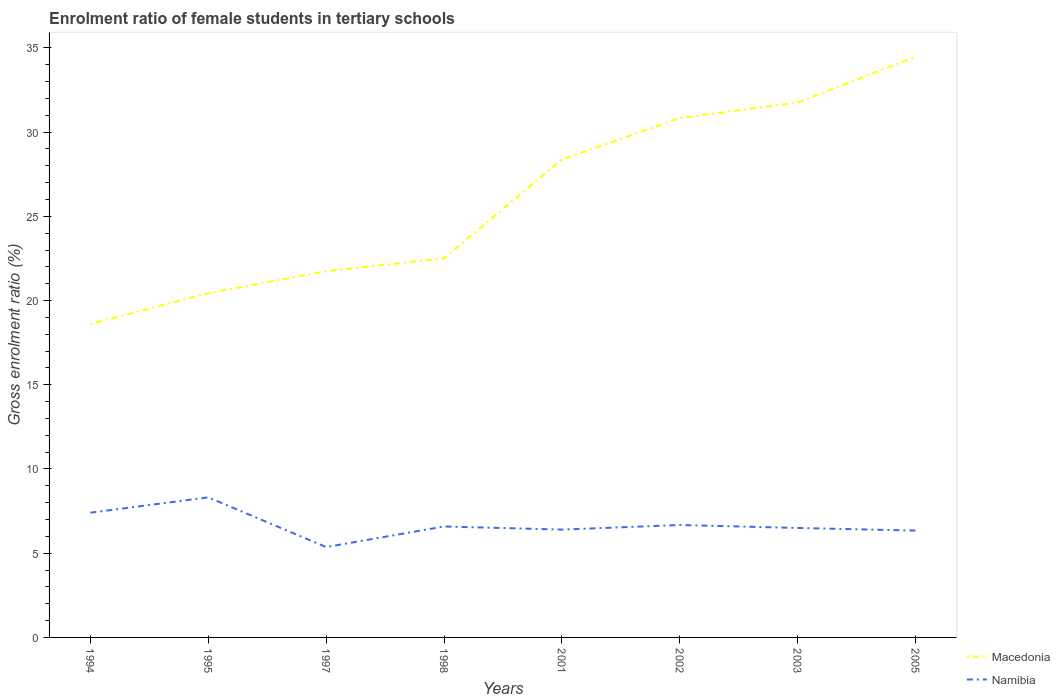How many different coloured lines are there?
Offer a terse response. 2. Does the line corresponding to Macedonia intersect with the line corresponding to Namibia?
Make the answer very short. No. Is the number of lines equal to the number of legend labels?
Your answer should be compact. Yes. Across all years, what is the maximum enrolment ratio of female students in tertiary schools in Namibia?
Offer a terse response. 5.36. In which year was the enrolment ratio of female students in tertiary schools in Namibia maximum?
Keep it short and to the point. 1997. What is the total enrolment ratio of female students in tertiary schools in Macedonia in the graph?
Provide a short and direct response. -2.45. What is the difference between the highest and the second highest enrolment ratio of female students in tertiary schools in Macedonia?
Give a very brief answer. 15.86. What is the difference between the highest and the lowest enrolment ratio of female students in tertiary schools in Namibia?
Ensure brevity in your answer.  2. How many years are there in the graph?
Keep it short and to the point. 8. Does the graph contain any zero values?
Your response must be concise. No. How many legend labels are there?
Make the answer very short. 2. What is the title of the graph?
Ensure brevity in your answer.  Enrolment ratio of female students in tertiary schools. What is the Gross enrolment ratio (%) in Macedonia in 1994?
Offer a very short reply. 18.61. What is the Gross enrolment ratio (%) in Namibia in 1994?
Ensure brevity in your answer.  7.41. What is the Gross enrolment ratio (%) in Macedonia in 1995?
Make the answer very short. 20.43. What is the Gross enrolment ratio (%) in Namibia in 1995?
Your response must be concise. 8.32. What is the Gross enrolment ratio (%) in Macedonia in 1997?
Give a very brief answer. 21.74. What is the Gross enrolment ratio (%) of Namibia in 1997?
Your answer should be very brief. 5.36. What is the Gross enrolment ratio (%) of Macedonia in 1998?
Your response must be concise. 22.5. What is the Gross enrolment ratio (%) in Namibia in 1998?
Keep it short and to the point. 6.59. What is the Gross enrolment ratio (%) of Macedonia in 2001?
Provide a short and direct response. 28.38. What is the Gross enrolment ratio (%) in Namibia in 2001?
Ensure brevity in your answer.  6.4. What is the Gross enrolment ratio (%) of Macedonia in 2002?
Provide a succinct answer. 30.83. What is the Gross enrolment ratio (%) of Namibia in 2002?
Provide a succinct answer. 6.67. What is the Gross enrolment ratio (%) in Macedonia in 2003?
Provide a succinct answer. 31.76. What is the Gross enrolment ratio (%) of Namibia in 2003?
Your response must be concise. 6.5. What is the Gross enrolment ratio (%) of Macedonia in 2005?
Provide a short and direct response. 34.47. What is the Gross enrolment ratio (%) in Namibia in 2005?
Keep it short and to the point. 6.34. Across all years, what is the maximum Gross enrolment ratio (%) in Macedonia?
Provide a short and direct response. 34.47. Across all years, what is the maximum Gross enrolment ratio (%) of Namibia?
Provide a short and direct response. 8.32. Across all years, what is the minimum Gross enrolment ratio (%) in Macedonia?
Give a very brief answer. 18.61. Across all years, what is the minimum Gross enrolment ratio (%) in Namibia?
Your answer should be very brief. 5.36. What is the total Gross enrolment ratio (%) in Macedonia in the graph?
Give a very brief answer. 208.73. What is the total Gross enrolment ratio (%) in Namibia in the graph?
Your answer should be compact. 53.59. What is the difference between the Gross enrolment ratio (%) in Macedonia in 1994 and that in 1995?
Keep it short and to the point. -1.82. What is the difference between the Gross enrolment ratio (%) in Namibia in 1994 and that in 1995?
Give a very brief answer. -0.91. What is the difference between the Gross enrolment ratio (%) in Macedonia in 1994 and that in 1997?
Your answer should be very brief. -3.13. What is the difference between the Gross enrolment ratio (%) of Namibia in 1994 and that in 1997?
Keep it short and to the point. 2.04. What is the difference between the Gross enrolment ratio (%) in Macedonia in 1994 and that in 1998?
Ensure brevity in your answer.  -3.89. What is the difference between the Gross enrolment ratio (%) in Namibia in 1994 and that in 1998?
Ensure brevity in your answer.  0.82. What is the difference between the Gross enrolment ratio (%) in Macedonia in 1994 and that in 2001?
Offer a very short reply. -9.77. What is the difference between the Gross enrolment ratio (%) in Namibia in 1994 and that in 2001?
Keep it short and to the point. 1. What is the difference between the Gross enrolment ratio (%) of Macedonia in 1994 and that in 2002?
Offer a very short reply. -12.22. What is the difference between the Gross enrolment ratio (%) in Namibia in 1994 and that in 2002?
Offer a terse response. 0.73. What is the difference between the Gross enrolment ratio (%) of Macedonia in 1994 and that in 2003?
Ensure brevity in your answer.  -13.15. What is the difference between the Gross enrolment ratio (%) in Namibia in 1994 and that in 2003?
Offer a terse response. 0.91. What is the difference between the Gross enrolment ratio (%) in Macedonia in 1994 and that in 2005?
Your answer should be compact. -15.86. What is the difference between the Gross enrolment ratio (%) of Namibia in 1994 and that in 2005?
Give a very brief answer. 1.06. What is the difference between the Gross enrolment ratio (%) of Macedonia in 1995 and that in 1997?
Provide a succinct answer. -1.31. What is the difference between the Gross enrolment ratio (%) of Namibia in 1995 and that in 1997?
Your response must be concise. 2.95. What is the difference between the Gross enrolment ratio (%) of Macedonia in 1995 and that in 1998?
Provide a short and direct response. -2.07. What is the difference between the Gross enrolment ratio (%) in Namibia in 1995 and that in 1998?
Your answer should be compact. 1.73. What is the difference between the Gross enrolment ratio (%) in Macedonia in 1995 and that in 2001?
Your answer should be compact. -7.94. What is the difference between the Gross enrolment ratio (%) in Namibia in 1995 and that in 2001?
Your answer should be very brief. 1.91. What is the difference between the Gross enrolment ratio (%) of Macedonia in 1995 and that in 2002?
Your answer should be compact. -10.39. What is the difference between the Gross enrolment ratio (%) in Namibia in 1995 and that in 2002?
Your response must be concise. 1.64. What is the difference between the Gross enrolment ratio (%) in Macedonia in 1995 and that in 2003?
Offer a terse response. -11.32. What is the difference between the Gross enrolment ratio (%) in Namibia in 1995 and that in 2003?
Make the answer very short. 1.82. What is the difference between the Gross enrolment ratio (%) in Macedonia in 1995 and that in 2005?
Provide a short and direct response. -14.04. What is the difference between the Gross enrolment ratio (%) of Namibia in 1995 and that in 2005?
Provide a short and direct response. 1.97. What is the difference between the Gross enrolment ratio (%) of Macedonia in 1997 and that in 1998?
Make the answer very short. -0.76. What is the difference between the Gross enrolment ratio (%) in Namibia in 1997 and that in 1998?
Your answer should be compact. -1.22. What is the difference between the Gross enrolment ratio (%) of Macedonia in 1997 and that in 2001?
Make the answer very short. -6.64. What is the difference between the Gross enrolment ratio (%) of Namibia in 1997 and that in 2001?
Your answer should be compact. -1.04. What is the difference between the Gross enrolment ratio (%) of Macedonia in 1997 and that in 2002?
Ensure brevity in your answer.  -9.09. What is the difference between the Gross enrolment ratio (%) in Namibia in 1997 and that in 2002?
Your answer should be compact. -1.31. What is the difference between the Gross enrolment ratio (%) in Macedonia in 1997 and that in 2003?
Offer a terse response. -10.02. What is the difference between the Gross enrolment ratio (%) in Namibia in 1997 and that in 2003?
Offer a very short reply. -1.14. What is the difference between the Gross enrolment ratio (%) in Macedonia in 1997 and that in 2005?
Your response must be concise. -12.73. What is the difference between the Gross enrolment ratio (%) of Namibia in 1997 and that in 2005?
Keep it short and to the point. -0.98. What is the difference between the Gross enrolment ratio (%) in Macedonia in 1998 and that in 2001?
Your answer should be compact. -5.88. What is the difference between the Gross enrolment ratio (%) of Namibia in 1998 and that in 2001?
Make the answer very short. 0.18. What is the difference between the Gross enrolment ratio (%) in Macedonia in 1998 and that in 2002?
Give a very brief answer. -8.33. What is the difference between the Gross enrolment ratio (%) of Namibia in 1998 and that in 2002?
Your answer should be compact. -0.09. What is the difference between the Gross enrolment ratio (%) in Macedonia in 1998 and that in 2003?
Provide a short and direct response. -9.26. What is the difference between the Gross enrolment ratio (%) of Namibia in 1998 and that in 2003?
Give a very brief answer. 0.09. What is the difference between the Gross enrolment ratio (%) in Macedonia in 1998 and that in 2005?
Provide a succinct answer. -11.97. What is the difference between the Gross enrolment ratio (%) of Namibia in 1998 and that in 2005?
Give a very brief answer. 0.24. What is the difference between the Gross enrolment ratio (%) in Macedonia in 2001 and that in 2002?
Your answer should be compact. -2.45. What is the difference between the Gross enrolment ratio (%) of Namibia in 2001 and that in 2002?
Ensure brevity in your answer.  -0.27. What is the difference between the Gross enrolment ratio (%) in Macedonia in 2001 and that in 2003?
Make the answer very short. -3.38. What is the difference between the Gross enrolment ratio (%) of Namibia in 2001 and that in 2003?
Offer a terse response. -0.1. What is the difference between the Gross enrolment ratio (%) in Macedonia in 2001 and that in 2005?
Provide a short and direct response. -6.09. What is the difference between the Gross enrolment ratio (%) in Namibia in 2001 and that in 2005?
Provide a short and direct response. 0.06. What is the difference between the Gross enrolment ratio (%) in Macedonia in 2002 and that in 2003?
Your answer should be very brief. -0.93. What is the difference between the Gross enrolment ratio (%) of Namibia in 2002 and that in 2003?
Provide a succinct answer. 0.18. What is the difference between the Gross enrolment ratio (%) in Macedonia in 2002 and that in 2005?
Your answer should be very brief. -3.64. What is the difference between the Gross enrolment ratio (%) of Namibia in 2002 and that in 2005?
Your answer should be very brief. 0.33. What is the difference between the Gross enrolment ratio (%) of Macedonia in 2003 and that in 2005?
Give a very brief answer. -2.71. What is the difference between the Gross enrolment ratio (%) in Namibia in 2003 and that in 2005?
Ensure brevity in your answer.  0.16. What is the difference between the Gross enrolment ratio (%) of Macedonia in 1994 and the Gross enrolment ratio (%) of Namibia in 1995?
Make the answer very short. 10.29. What is the difference between the Gross enrolment ratio (%) in Macedonia in 1994 and the Gross enrolment ratio (%) in Namibia in 1997?
Provide a succinct answer. 13.25. What is the difference between the Gross enrolment ratio (%) of Macedonia in 1994 and the Gross enrolment ratio (%) of Namibia in 1998?
Your answer should be very brief. 12.02. What is the difference between the Gross enrolment ratio (%) of Macedonia in 1994 and the Gross enrolment ratio (%) of Namibia in 2001?
Make the answer very short. 12.21. What is the difference between the Gross enrolment ratio (%) of Macedonia in 1994 and the Gross enrolment ratio (%) of Namibia in 2002?
Make the answer very short. 11.94. What is the difference between the Gross enrolment ratio (%) in Macedonia in 1994 and the Gross enrolment ratio (%) in Namibia in 2003?
Provide a short and direct response. 12.11. What is the difference between the Gross enrolment ratio (%) of Macedonia in 1994 and the Gross enrolment ratio (%) of Namibia in 2005?
Keep it short and to the point. 12.27. What is the difference between the Gross enrolment ratio (%) in Macedonia in 1995 and the Gross enrolment ratio (%) in Namibia in 1997?
Provide a succinct answer. 15.07. What is the difference between the Gross enrolment ratio (%) of Macedonia in 1995 and the Gross enrolment ratio (%) of Namibia in 1998?
Ensure brevity in your answer.  13.85. What is the difference between the Gross enrolment ratio (%) in Macedonia in 1995 and the Gross enrolment ratio (%) in Namibia in 2001?
Keep it short and to the point. 14.03. What is the difference between the Gross enrolment ratio (%) of Macedonia in 1995 and the Gross enrolment ratio (%) of Namibia in 2002?
Give a very brief answer. 13.76. What is the difference between the Gross enrolment ratio (%) of Macedonia in 1995 and the Gross enrolment ratio (%) of Namibia in 2003?
Your response must be concise. 13.94. What is the difference between the Gross enrolment ratio (%) in Macedonia in 1995 and the Gross enrolment ratio (%) in Namibia in 2005?
Your response must be concise. 14.09. What is the difference between the Gross enrolment ratio (%) in Macedonia in 1997 and the Gross enrolment ratio (%) in Namibia in 1998?
Provide a succinct answer. 15.16. What is the difference between the Gross enrolment ratio (%) of Macedonia in 1997 and the Gross enrolment ratio (%) of Namibia in 2001?
Provide a short and direct response. 15.34. What is the difference between the Gross enrolment ratio (%) of Macedonia in 1997 and the Gross enrolment ratio (%) of Namibia in 2002?
Offer a very short reply. 15.07. What is the difference between the Gross enrolment ratio (%) in Macedonia in 1997 and the Gross enrolment ratio (%) in Namibia in 2003?
Offer a very short reply. 15.24. What is the difference between the Gross enrolment ratio (%) of Macedonia in 1997 and the Gross enrolment ratio (%) of Namibia in 2005?
Keep it short and to the point. 15.4. What is the difference between the Gross enrolment ratio (%) in Macedonia in 1998 and the Gross enrolment ratio (%) in Namibia in 2001?
Provide a short and direct response. 16.1. What is the difference between the Gross enrolment ratio (%) in Macedonia in 1998 and the Gross enrolment ratio (%) in Namibia in 2002?
Offer a terse response. 15.83. What is the difference between the Gross enrolment ratio (%) of Macedonia in 1998 and the Gross enrolment ratio (%) of Namibia in 2003?
Keep it short and to the point. 16. What is the difference between the Gross enrolment ratio (%) in Macedonia in 1998 and the Gross enrolment ratio (%) in Namibia in 2005?
Give a very brief answer. 16.16. What is the difference between the Gross enrolment ratio (%) in Macedonia in 2001 and the Gross enrolment ratio (%) in Namibia in 2002?
Make the answer very short. 21.7. What is the difference between the Gross enrolment ratio (%) in Macedonia in 2001 and the Gross enrolment ratio (%) in Namibia in 2003?
Your answer should be very brief. 21.88. What is the difference between the Gross enrolment ratio (%) in Macedonia in 2001 and the Gross enrolment ratio (%) in Namibia in 2005?
Provide a succinct answer. 22.04. What is the difference between the Gross enrolment ratio (%) in Macedonia in 2002 and the Gross enrolment ratio (%) in Namibia in 2003?
Provide a short and direct response. 24.33. What is the difference between the Gross enrolment ratio (%) of Macedonia in 2002 and the Gross enrolment ratio (%) of Namibia in 2005?
Give a very brief answer. 24.49. What is the difference between the Gross enrolment ratio (%) in Macedonia in 2003 and the Gross enrolment ratio (%) in Namibia in 2005?
Provide a short and direct response. 25.42. What is the average Gross enrolment ratio (%) of Macedonia per year?
Provide a short and direct response. 26.09. What is the average Gross enrolment ratio (%) in Namibia per year?
Your answer should be compact. 6.7. In the year 1994, what is the difference between the Gross enrolment ratio (%) in Macedonia and Gross enrolment ratio (%) in Namibia?
Offer a very short reply. 11.21. In the year 1995, what is the difference between the Gross enrolment ratio (%) in Macedonia and Gross enrolment ratio (%) in Namibia?
Your answer should be very brief. 12.12. In the year 1997, what is the difference between the Gross enrolment ratio (%) in Macedonia and Gross enrolment ratio (%) in Namibia?
Your answer should be very brief. 16.38. In the year 1998, what is the difference between the Gross enrolment ratio (%) in Macedonia and Gross enrolment ratio (%) in Namibia?
Your answer should be very brief. 15.92. In the year 2001, what is the difference between the Gross enrolment ratio (%) in Macedonia and Gross enrolment ratio (%) in Namibia?
Your answer should be compact. 21.98. In the year 2002, what is the difference between the Gross enrolment ratio (%) in Macedonia and Gross enrolment ratio (%) in Namibia?
Give a very brief answer. 24.15. In the year 2003, what is the difference between the Gross enrolment ratio (%) of Macedonia and Gross enrolment ratio (%) of Namibia?
Give a very brief answer. 25.26. In the year 2005, what is the difference between the Gross enrolment ratio (%) in Macedonia and Gross enrolment ratio (%) in Namibia?
Keep it short and to the point. 28.13. What is the ratio of the Gross enrolment ratio (%) of Macedonia in 1994 to that in 1995?
Your response must be concise. 0.91. What is the ratio of the Gross enrolment ratio (%) of Namibia in 1994 to that in 1995?
Offer a very short reply. 0.89. What is the ratio of the Gross enrolment ratio (%) of Macedonia in 1994 to that in 1997?
Give a very brief answer. 0.86. What is the ratio of the Gross enrolment ratio (%) of Namibia in 1994 to that in 1997?
Offer a very short reply. 1.38. What is the ratio of the Gross enrolment ratio (%) in Macedonia in 1994 to that in 1998?
Offer a very short reply. 0.83. What is the ratio of the Gross enrolment ratio (%) in Namibia in 1994 to that in 1998?
Your response must be concise. 1.12. What is the ratio of the Gross enrolment ratio (%) in Macedonia in 1994 to that in 2001?
Provide a succinct answer. 0.66. What is the ratio of the Gross enrolment ratio (%) in Namibia in 1994 to that in 2001?
Your answer should be compact. 1.16. What is the ratio of the Gross enrolment ratio (%) of Macedonia in 1994 to that in 2002?
Give a very brief answer. 0.6. What is the ratio of the Gross enrolment ratio (%) in Namibia in 1994 to that in 2002?
Your answer should be compact. 1.11. What is the ratio of the Gross enrolment ratio (%) in Macedonia in 1994 to that in 2003?
Keep it short and to the point. 0.59. What is the ratio of the Gross enrolment ratio (%) of Namibia in 1994 to that in 2003?
Give a very brief answer. 1.14. What is the ratio of the Gross enrolment ratio (%) of Macedonia in 1994 to that in 2005?
Your response must be concise. 0.54. What is the ratio of the Gross enrolment ratio (%) in Namibia in 1994 to that in 2005?
Offer a terse response. 1.17. What is the ratio of the Gross enrolment ratio (%) of Macedonia in 1995 to that in 1997?
Offer a very short reply. 0.94. What is the ratio of the Gross enrolment ratio (%) of Namibia in 1995 to that in 1997?
Provide a short and direct response. 1.55. What is the ratio of the Gross enrolment ratio (%) in Macedonia in 1995 to that in 1998?
Keep it short and to the point. 0.91. What is the ratio of the Gross enrolment ratio (%) in Namibia in 1995 to that in 1998?
Your response must be concise. 1.26. What is the ratio of the Gross enrolment ratio (%) in Macedonia in 1995 to that in 2001?
Offer a terse response. 0.72. What is the ratio of the Gross enrolment ratio (%) of Namibia in 1995 to that in 2001?
Make the answer very short. 1.3. What is the ratio of the Gross enrolment ratio (%) of Macedonia in 1995 to that in 2002?
Make the answer very short. 0.66. What is the ratio of the Gross enrolment ratio (%) in Namibia in 1995 to that in 2002?
Offer a very short reply. 1.25. What is the ratio of the Gross enrolment ratio (%) of Macedonia in 1995 to that in 2003?
Give a very brief answer. 0.64. What is the ratio of the Gross enrolment ratio (%) in Namibia in 1995 to that in 2003?
Keep it short and to the point. 1.28. What is the ratio of the Gross enrolment ratio (%) of Macedonia in 1995 to that in 2005?
Ensure brevity in your answer.  0.59. What is the ratio of the Gross enrolment ratio (%) of Namibia in 1995 to that in 2005?
Give a very brief answer. 1.31. What is the ratio of the Gross enrolment ratio (%) in Macedonia in 1997 to that in 1998?
Keep it short and to the point. 0.97. What is the ratio of the Gross enrolment ratio (%) in Namibia in 1997 to that in 1998?
Offer a very short reply. 0.81. What is the ratio of the Gross enrolment ratio (%) in Macedonia in 1997 to that in 2001?
Offer a very short reply. 0.77. What is the ratio of the Gross enrolment ratio (%) of Namibia in 1997 to that in 2001?
Offer a terse response. 0.84. What is the ratio of the Gross enrolment ratio (%) in Macedonia in 1997 to that in 2002?
Make the answer very short. 0.71. What is the ratio of the Gross enrolment ratio (%) of Namibia in 1997 to that in 2002?
Ensure brevity in your answer.  0.8. What is the ratio of the Gross enrolment ratio (%) in Macedonia in 1997 to that in 2003?
Offer a terse response. 0.68. What is the ratio of the Gross enrolment ratio (%) in Namibia in 1997 to that in 2003?
Ensure brevity in your answer.  0.83. What is the ratio of the Gross enrolment ratio (%) in Macedonia in 1997 to that in 2005?
Keep it short and to the point. 0.63. What is the ratio of the Gross enrolment ratio (%) in Namibia in 1997 to that in 2005?
Provide a short and direct response. 0.85. What is the ratio of the Gross enrolment ratio (%) in Macedonia in 1998 to that in 2001?
Ensure brevity in your answer.  0.79. What is the ratio of the Gross enrolment ratio (%) of Namibia in 1998 to that in 2001?
Offer a terse response. 1.03. What is the ratio of the Gross enrolment ratio (%) of Macedonia in 1998 to that in 2002?
Offer a terse response. 0.73. What is the ratio of the Gross enrolment ratio (%) in Namibia in 1998 to that in 2002?
Ensure brevity in your answer.  0.99. What is the ratio of the Gross enrolment ratio (%) in Macedonia in 1998 to that in 2003?
Keep it short and to the point. 0.71. What is the ratio of the Gross enrolment ratio (%) of Namibia in 1998 to that in 2003?
Offer a very short reply. 1.01. What is the ratio of the Gross enrolment ratio (%) in Macedonia in 1998 to that in 2005?
Offer a very short reply. 0.65. What is the ratio of the Gross enrolment ratio (%) in Namibia in 1998 to that in 2005?
Provide a short and direct response. 1.04. What is the ratio of the Gross enrolment ratio (%) of Macedonia in 2001 to that in 2002?
Give a very brief answer. 0.92. What is the ratio of the Gross enrolment ratio (%) of Namibia in 2001 to that in 2002?
Your answer should be very brief. 0.96. What is the ratio of the Gross enrolment ratio (%) in Macedonia in 2001 to that in 2003?
Provide a succinct answer. 0.89. What is the ratio of the Gross enrolment ratio (%) in Namibia in 2001 to that in 2003?
Keep it short and to the point. 0.99. What is the ratio of the Gross enrolment ratio (%) of Macedonia in 2001 to that in 2005?
Your answer should be very brief. 0.82. What is the ratio of the Gross enrolment ratio (%) of Namibia in 2001 to that in 2005?
Offer a very short reply. 1.01. What is the ratio of the Gross enrolment ratio (%) of Macedonia in 2002 to that in 2003?
Your response must be concise. 0.97. What is the ratio of the Gross enrolment ratio (%) in Namibia in 2002 to that in 2003?
Your response must be concise. 1.03. What is the ratio of the Gross enrolment ratio (%) of Macedonia in 2002 to that in 2005?
Your answer should be very brief. 0.89. What is the ratio of the Gross enrolment ratio (%) in Namibia in 2002 to that in 2005?
Make the answer very short. 1.05. What is the ratio of the Gross enrolment ratio (%) of Macedonia in 2003 to that in 2005?
Your response must be concise. 0.92. What is the ratio of the Gross enrolment ratio (%) in Namibia in 2003 to that in 2005?
Offer a very short reply. 1.02. What is the difference between the highest and the second highest Gross enrolment ratio (%) of Macedonia?
Offer a terse response. 2.71. What is the difference between the highest and the second highest Gross enrolment ratio (%) of Namibia?
Your response must be concise. 0.91. What is the difference between the highest and the lowest Gross enrolment ratio (%) of Macedonia?
Your answer should be compact. 15.86. What is the difference between the highest and the lowest Gross enrolment ratio (%) of Namibia?
Keep it short and to the point. 2.95. 